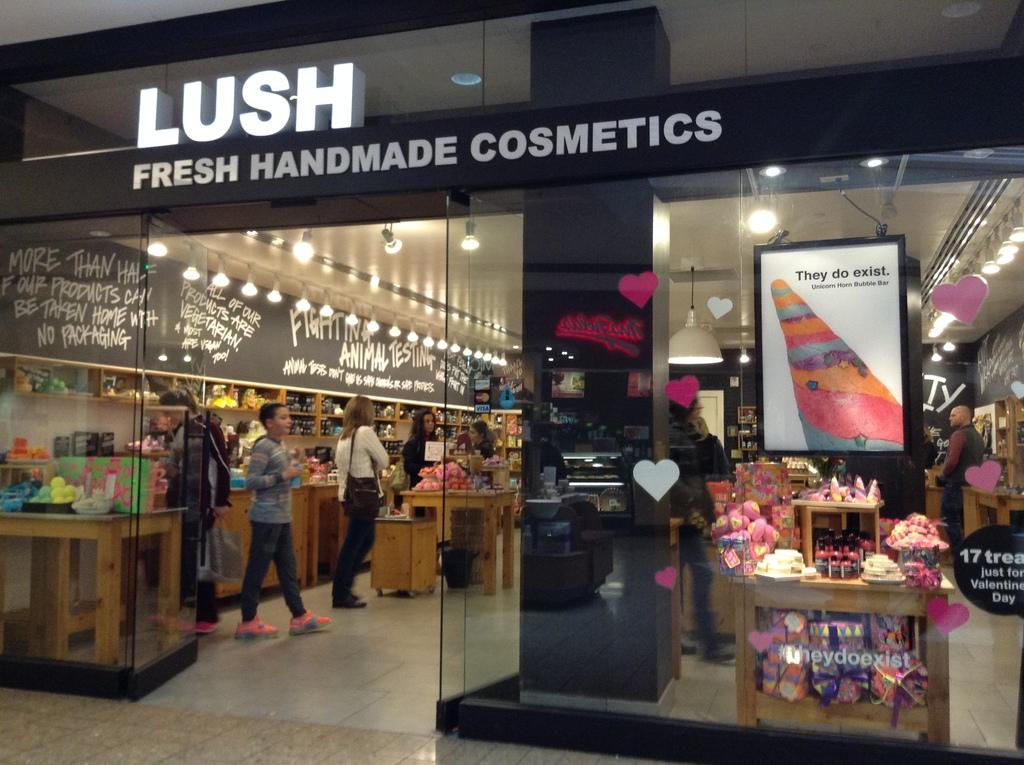What type of store is depicted in the image? There is a cosmetic store in the image. Are there any people present in the store? Yes, there are people in the store. What can be observed about the lighting in the store? There are lights in the store. What type of information is visible in the store? There is text visible in the store. Can you see any toads in the alley outside the store? There is no alley or toads present in the image; it only shows the interior of the cosmetic store. Are there any stockings for sale in the store? The provided facts do not mention stockings being sold in the store. 